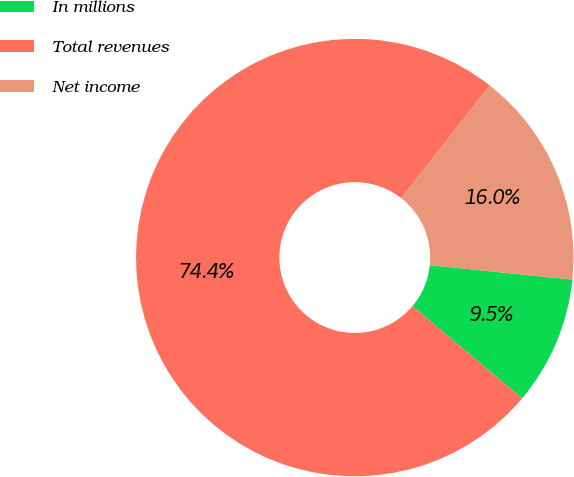Convert chart. <chart><loc_0><loc_0><loc_500><loc_500><pie_chart><fcel>In millions<fcel>Total revenues<fcel>Net income<nl><fcel>9.53%<fcel>74.45%<fcel>16.02%<nl></chart> 